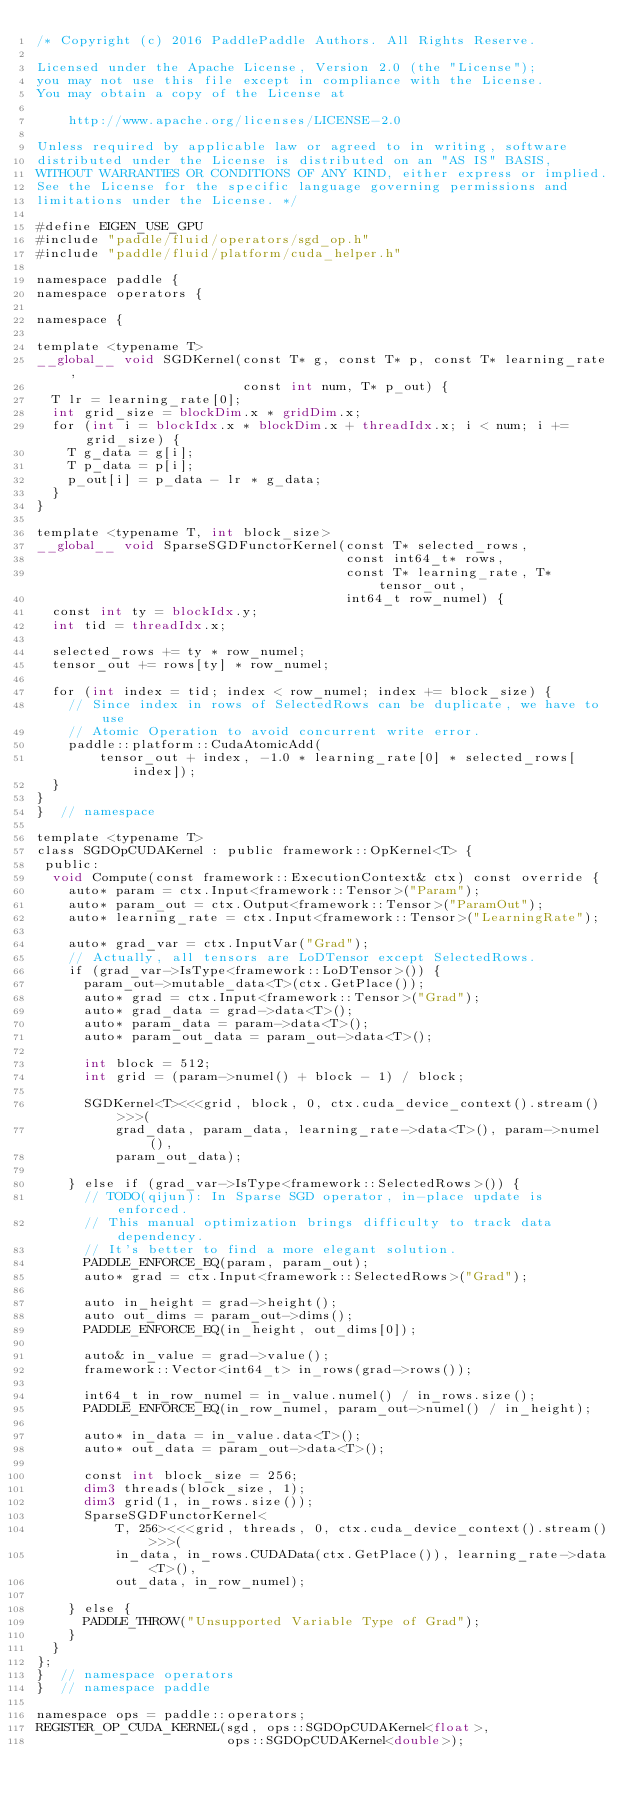Convert code to text. <code><loc_0><loc_0><loc_500><loc_500><_Cuda_>/* Copyright (c) 2016 PaddlePaddle Authors. All Rights Reserve.

Licensed under the Apache License, Version 2.0 (the "License");
you may not use this file except in compliance with the License.
You may obtain a copy of the License at

    http://www.apache.org/licenses/LICENSE-2.0

Unless required by applicable law or agreed to in writing, software
distributed under the License is distributed on an "AS IS" BASIS,
WITHOUT WARRANTIES OR CONDITIONS OF ANY KIND, either express or implied.
See the License for the specific language governing permissions and
limitations under the License. */

#define EIGEN_USE_GPU
#include "paddle/fluid/operators/sgd_op.h"
#include "paddle/fluid/platform/cuda_helper.h"

namespace paddle {
namespace operators {

namespace {

template <typename T>
__global__ void SGDKernel(const T* g, const T* p, const T* learning_rate,
                          const int num, T* p_out) {
  T lr = learning_rate[0];
  int grid_size = blockDim.x * gridDim.x;
  for (int i = blockIdx.x * blockDim.x + threadIdx.x; i < num; i += grid_size) {
    T g_data = g[i];
    T p_data = p[i];
    p_out[i] = p_data - lr * g_data;
  }
}

template <typename T, int block_size>
__global__ void SparseSGDFunctorKernel(const T* selected_rows,
                                       const int64_t* rows,
                                       const T* learning_rate, T* tensor_out,
                                       int64_t row_numel) {
  const int ty = blockIdx.y;
  int tid = threadIdx.x;

  selected_rows += ty * row_numel;
  tensor_out += rows[ty] * row_numel;

  for (int index = tid; index < row_numel; index += block_size) {
    // Since index in rows of SelectedRows can be duplicate, we have to use
    // Atomic Operation to avoid concurrent write error.
    paddle::platform::CudaAtomicAdd(
        tensor_out + index, -1.0 * learning_rate[0] * selected_rows[index]);
  }
}
}  // namespace

template <typename T>
class SGDOpCUDAKernel : public framework::OpKernel<T> {
 public:
  void Compute(const framework::ExecutionContext& ctx) const override {
    auto* param = ctx.Input<framework::Tensor>("Param");
    auto* param_out = ctx.Output<framework::Tensor>("ParamOut");
    auto* learning_rate = ctx.Input<framework::Tensor>("LearningRate");

    auto* grad_var = ctx.InputVar("Grad");
    // Actually, all tensors are LoDTensor except SelectedRows.
    if (grad_var->IsType<framework::LoDTensor>()) {
      param_out->mutable_data<T>(ctx.GetPlace());
      auto* grad = ctx.Input<framework::Tensor>("Grad");
      auto* grad_data = grad->data<T>();
      auto* param_data = param->data<T>();
      auto* param_out_data = param_out->data<T>();

      int block = 512;
      int grid = (param->numel() + block - 1) / block;

      SGDKernel<T><<<grid, block, 0, ctx.cuda_device_context().stream()>>>(
          grad_data, param_data, learning_rate->data<T>(), param->numel(),
          param_out_data);

    } else if (grad_var->IsType<framework::SelectedRows>()) {
      // TODO(qijun): In Sparse SGD operator, in-place update is enforced.
      // This manual optimization brings difficulty to track data dependency.
      // It's better to find a more elegant solution.
      PADDLE_ENFORCE_EQ(param, param_out);
      auto* grad = ctx.Input<framework::SelectedRows>("Grad");

      auto in_height = grad->height();
      auto out_dims = param_out->dims();
      PADDLE_ENFORCE_EQ(in_height, out_dims[0]);

      auto& in_value = grad->value();
      framework::Vector<int64_t> in_rows(grad->rows());

      int64_t in_row_numel = in_value.numel() / in_rows.size();
      PADDLE_ENFORCE_EQ(in_row_numel, param_out->numel() / in_height);

      auto* in_data = in_value.data<T>();
      auto* out_data = param_out->data<T>();

      const int block_size = 256;
      dim3 threads(block_size, 1);
      dim3 grid(1, in_rows.size());
      SparseSGDFunctorKernel<
          T, 256><<<grid, threads, 0, ctx.cuda_device_context().stream()>>>(
          in_data, in_rows.CUDAData(ctx.GetPlace()), learning_rate->data<T>(),
          out_data, in_row_numel);

    } else {
      PADDLE_THROW("Unsupported Variable Type of Grad");
    }
  }
};
}  // namespace operators
}  // namespace paddle

namespace ops = paddle::operators;
REGISTER_OP_CUDA_KERNEL(sgd, ops::SGDOpCUDAKernel<float>,
                        ops::SGDOpCUDAKernel<double>);
</code> 